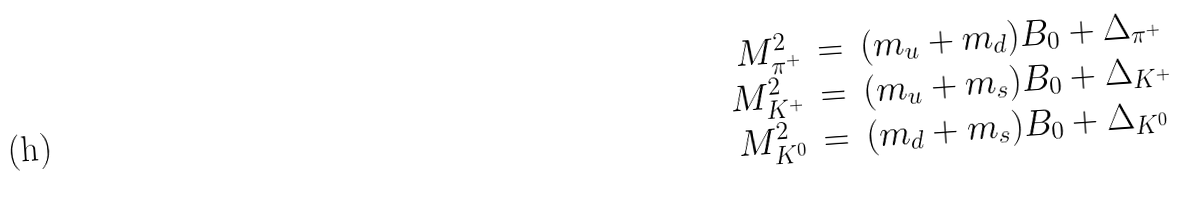Convert formula to latex. <formula><loc_0><loc_0><loc_500><loc_500>\begin{array} { r c l } M ^ { 2 } _ { \pi ^ { + } } & = & ( m _ { u } + m _ { d } ) B _ { 0 } + \Delta _ { \pi ^ { + } } \\ M ^ { 2 } _ { K ^ { + } } & = & ( m _ { u } + m _ { s } ) B _ { 0 } + \Delta _ { K ^ { + } } \\ M ^ { 2 } _ { K ^ { 0 } } & = & ( m _ { d } + m _ { s } ) B _ { 0 } + \Delta _ { K ^ { 0 } } \end{array}</formula> 